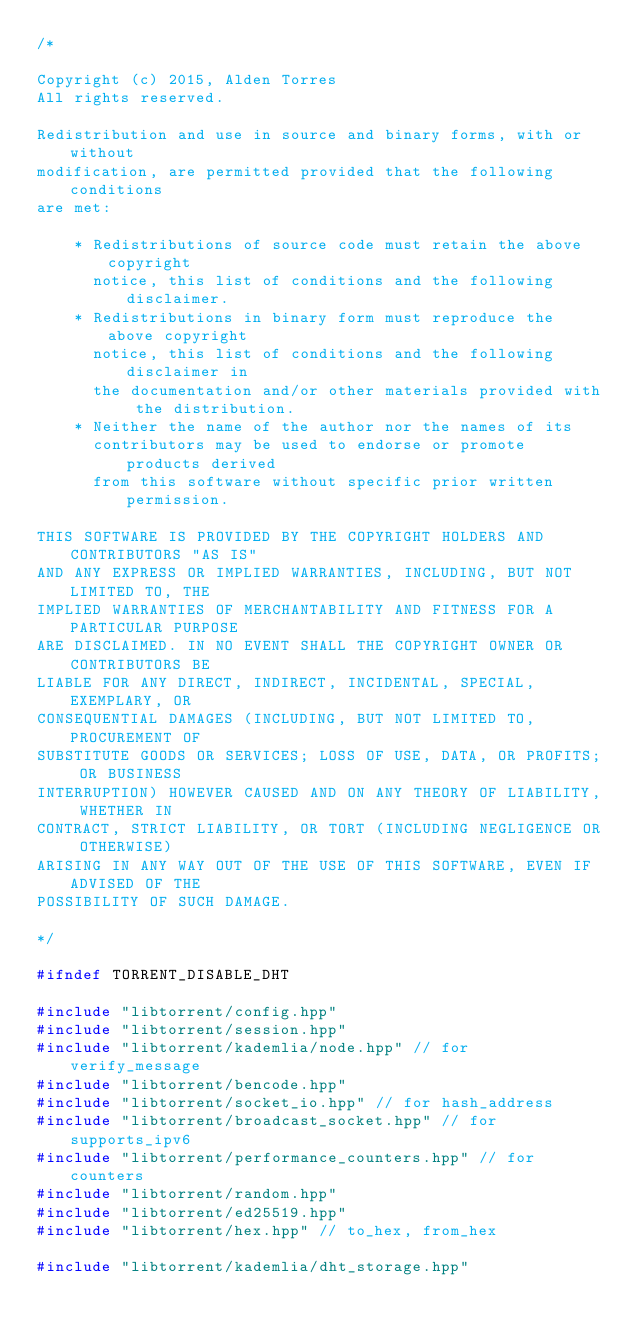<code> <loc_0><loc_0><loc_500><loc_500><_C++_>/*

Copyright (c) 2015, Alden Torres
All rights reserved.

Redistribution and use in source and binary forms, with or without
modification, are permitted provided that the following conditions
are met:

    * Redistributions of source code must retain the above copyright
      notice, this list of conditions and the following disclaimer.
    * Redistributions in binary form must reproduce the above copyright
      notice, this list of conditions and the following disclaimer in
      the documentation and/or other materials provided with the distribution.
    * Neither the name of the author nor the names of its
      contributors may be used to endorse or promote products derived
      from this software without specific prior written permission.

THIS SOFTWARE IS PROVIDED BY THE COPYRIGHT HOLDERS AND CONTRIBUTORS "AS IS"
AND ANY EXPRESS OR IMPLIED WARRANTIES, INCLUDING, BUT NOT LIMITED TO, THE
IMPLIED WARRANTIES OF MERCHANTABILITY AND FITNESS FOR A PARTICULAR PURPOSE
ARE DISCLAIMED. IN NO EVENT SHALL THE COPYRIGHT OWNER OR CONTRIBUTORS BE
LIABLE FOR ANY DIRECT, INDIRECT, INCIDENTAL, SPECIAL, EXEMPLARY, OR
CONSEQUENTIAL DAMAGES (INCLUDING, BUT NOT LIMITED TO, PROCUREMENT OF
SUBSTITUTE GOODS OR SERVICES; LOSS OF USE, DATA, OR PROFITS; OR BUSINESS
INTERRUPTION) HOWEVER CAUSED AND ON ANY THEORY OF LIABILITY, WHETHER IN
CONTRACT, STRICT LIABILITY, OR TORT (INCLUDING NEGLIGENCE OR OTHERWISE)
ARISING IN ANY WAY OUT OF THE USE OF THIS SOFTWARE, EVEN IF ADVISED OF THE
POSSIBILITY OF SUCH DAMAGE.

*/

#ifndef TORRENT_DISABLE_DHT

#include "libtorrent/config.hpp"
#include "libtorrent/session.hpp"
#include "libtorrent/kademlia/node.hpp" // for verify_message
#include "libtorrent/bencode.hpp"
#include "libtorrent/socket_io.hpp" // for hash_address
#include "libtorrent/broadcast_socket.hpp" // for supports_ipv6
#include "libtorrent/performance_counters.hpp" // for counters
#include "libtorrent/random.hpp"
#include "libtorrent/ed25519.hpp"
#include "libtorrent/hex.hpp" // to_hex, from_hex

#include "libtorrent/kademlia/dht_storage.hpp"</code> 